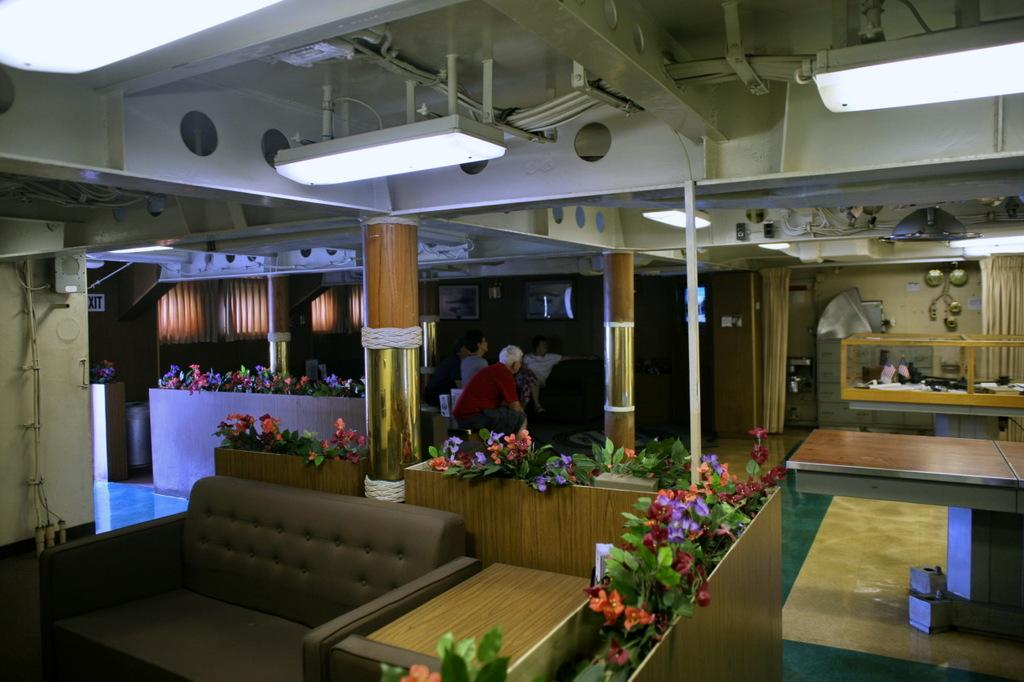What type of space is shown in the image? The image depicts a room. What piece of furniture can be seen in the room? There is a couch in the room. What decorative element is present in the room? There are flowers in the room. How many people are in the room? There are persons in the room. What is used for illumination in the room? There are lights in the room. What type of furniture is used for placing objects in the room? There are tables in the room. What type of whistle can be heard in the room? There is no whistle present or audible in the image, as it is a still photograph. 